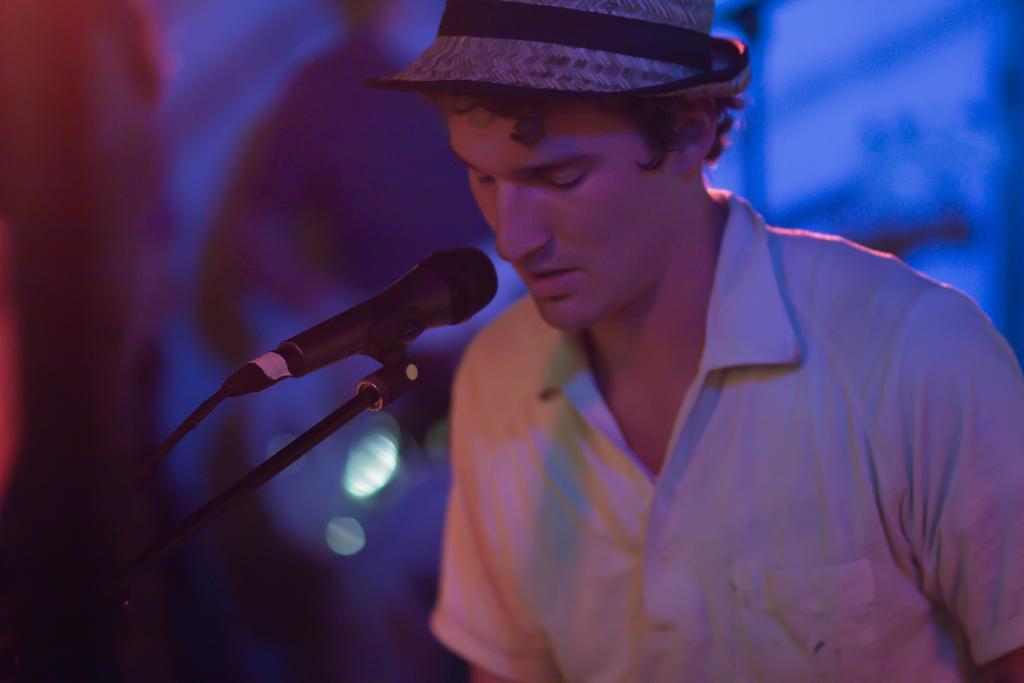Please provide a concise description of this image. In this image I can see a person standing and singing in front of a microphone. The person is wearing white shirt, black pant and I can see blue color background. 